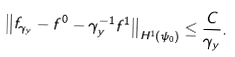<formula> <loc_0><loc_0><loc_500><loc_500>\left \| f _ { \gamma _ { y } } - f ^ { 0 } - \gamma _ { y } ^ { - 1 } f ^ { 1 } \right \| _ { H ^ { 1 } ( \psi _ { 0 } ) } \leq \frac { C } { \gamma _ { y } } .</formula> 